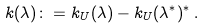Convert formula to latex. <formula><loc_0><loc_0><loc_500><loc_500>k ( \lambda ) \colon = k _ { U } ( \lambda ) - k _ { U } ( \lambda ^ { * } ) ^ { * } \, .</formula> 